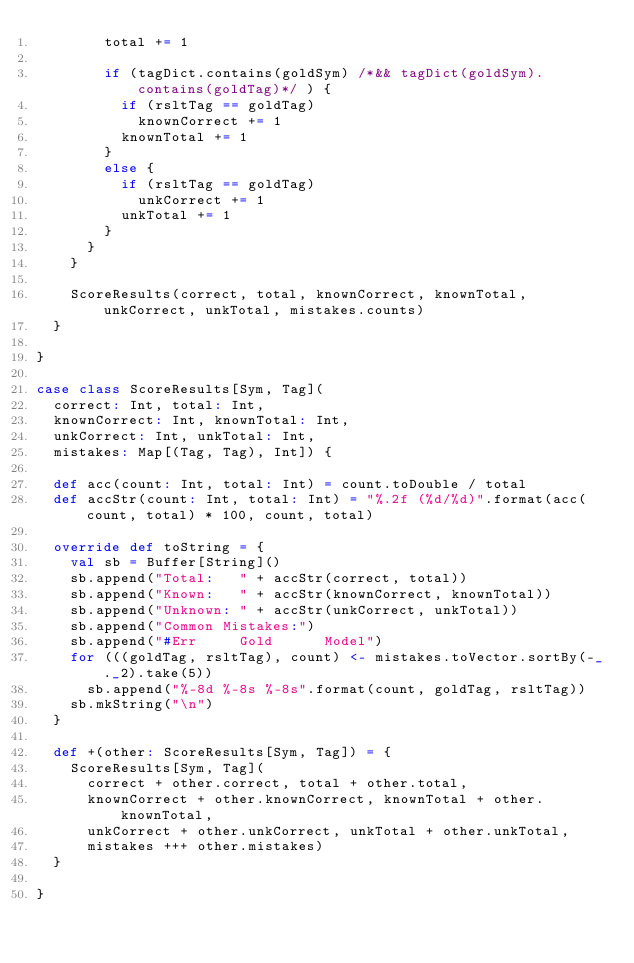Convert code to text. <code><loc_0><loc_0><loc_500><loc_500><_Scala_>        total += 1

        if (tagDict.contains(goldSym) /*&& tagDict(goldSym).contains(goldTag)*/ ) {
          if (rsltTag == goldTag)
            knownCorrect += 1
          knownTotal += 1
        }
        else {
          if (rsltTag == goldTag)
            unkCorrect += 1
          unkTotal += 1
        }
      }
    }

    ScoreResults(correct, total, knownCorrect, knownTotal, unkCorrect, unkTotal, mistakes.counts)
  }

}

case class ScoreResults[Sym, Tag](
  correct: Int, total: Int,
  knownCorrect: Int, knownTotal: Int,
  unkCorrect: Int, unkTotal: Int,
  mistakes: Map[(Tag, Tag), Int]) {

  def acc(count: Int, total: Int) = count.toDouble / total
  def accStr(count: Int, total: Int) = "%.2f (%d/%d)".format(acc(count, total) * 100, count, total)

  override def toString = {
    val sb = Buffer[String]()
    sb.append("Total:   " + accStr(correct, total))
    sb.append("Known:   " + accStr(knownCorrect, knownTotal))
    sb.append("Unknown: " + accStr(unkCorrect, unkTotal))
    sb.append("Common Mistakes:")
    sb.append("#Err     Gold      Model")
    for (((goldTag, rsltTag), count) <- mistakes.toVector.sortBy(-_._2).take(5))
      sb.append("%-8d %-8s %-8s".format(count, goldTag, rsltTag))
    sb.mkString("\n")
  }

  def +(other: ScoreResults[Sym, Tag]) = {
    ScoreResults[Sym, Tag](
      correct + other.correct, total + other.total,
      knownCorrect + other.knownCorrect, knownTotal + other.knownTotal,
      unkCorrect + other.unkCorrect, unkTotal + other.unkTotal,
      mistakes +++ other.mistakes)
  }

}
</code> 